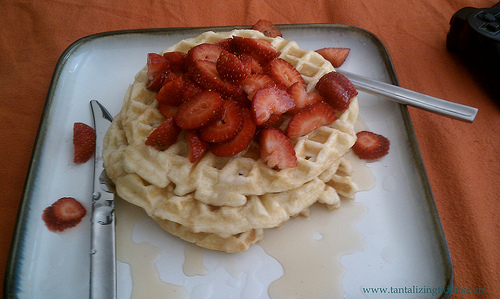<image>
Can you confirm if the table is under the waffles? Yes. The table is positioned underneath the waffles, with the waffles above it in the vertical space. Is there a strawberries on the waffles? Yes. Looking at the image, I can see the strawberries is positioned on top of the waffles, with the waffles providing support. 